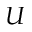Convert formula to latex. <formula><loc_0><loc_0><loc_500><loc_500>U</formula> 